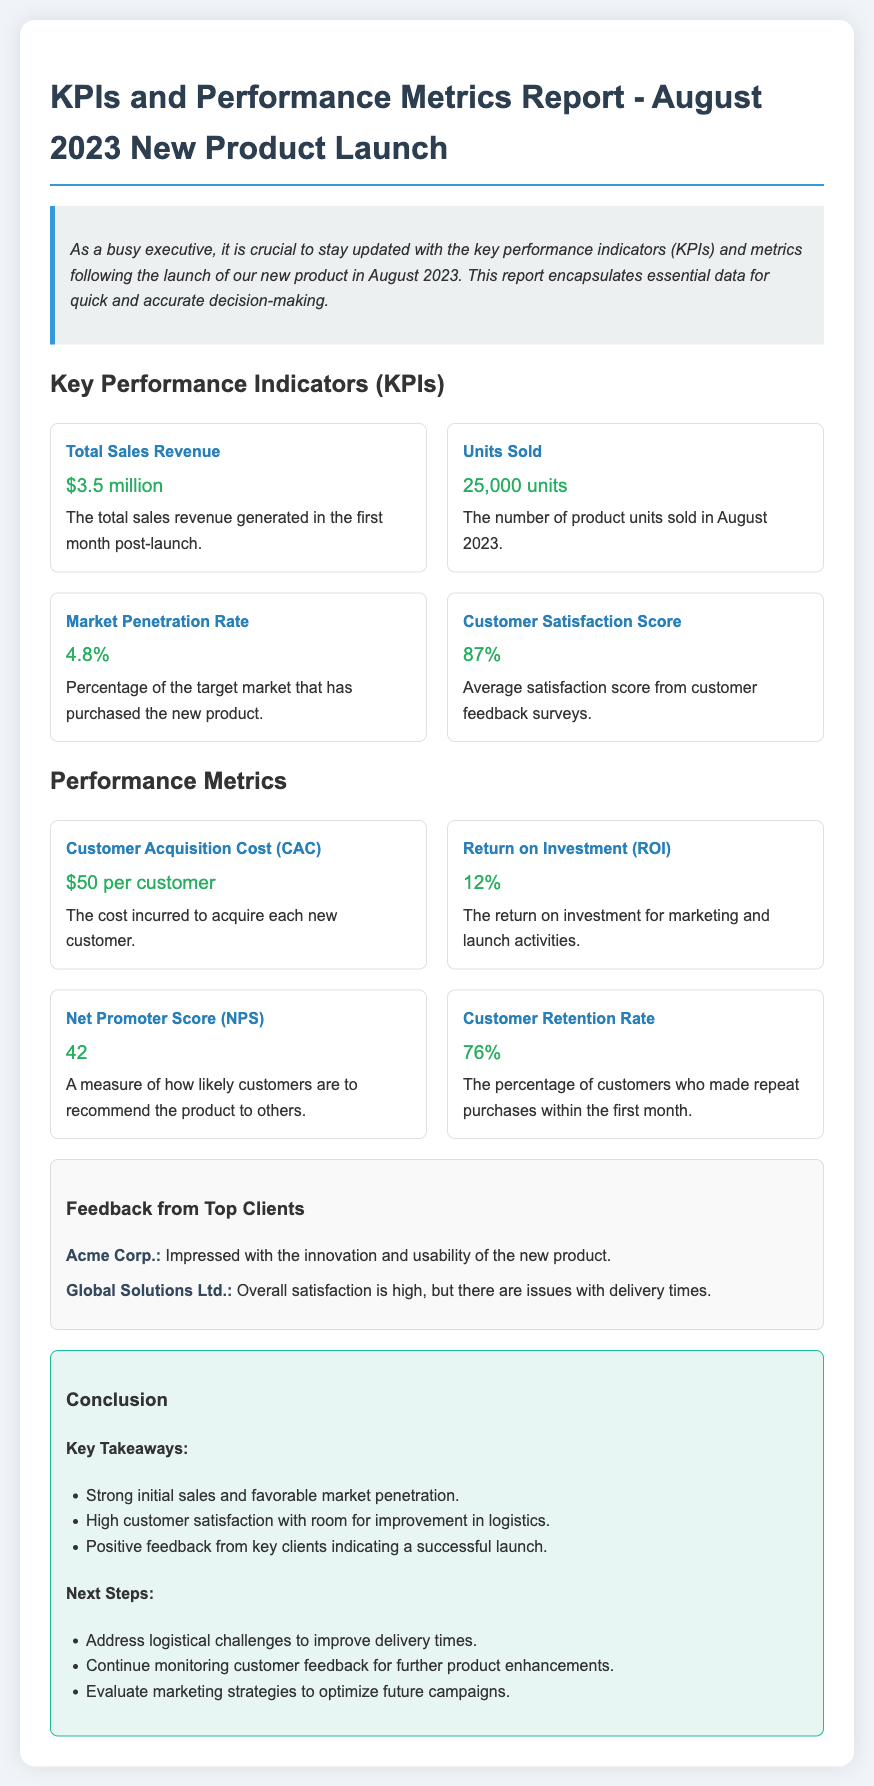what is the total sales revenue? The total sales revenue generated in the first month post-launch is stated as $3.5 million.
Answer: $3.5 million how many units were sold? The document specifies that 25,000 units were sold in August 2023.
Answer: 25,000 units what is the customer satisfaction score? The average satisfaction score from customer feedback surveys is presented as 87%.
Answer: 87% what is the customer acquisition cost? The cost incurred to acquire each new customer is noted as $50 per customer.
Answer: $50 per customer what percentage of the target market purchased the new product? The market penetration rate indicates that 4.8% of the target market has purchased the product.
Answer: 4.8% what is the Net Promoter Score? The document lists the Net Promoter Score as a measure of customer recommendation, which is 42.
Answer: 42 what is one logistical issue mentioned in the feedback? One of the feedback mentions that there are issues with delivery times.
Answer: delivery times what actions are suggested for the next steps? The next steps include addressing logistical challenges to improve delivery times.
Answer: improve delivery times how has the initial sales performance been described? The conclusion states that there was strong initial sales and favorable market penetration.
Answer: strong initial sales 